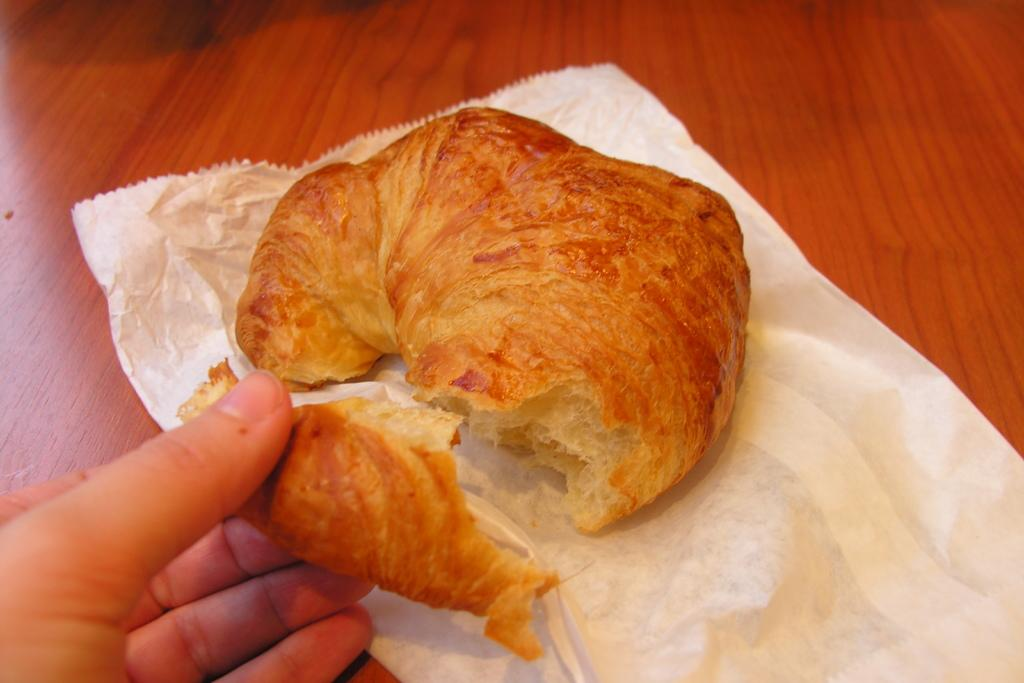What type of food is visible in the image? The food in the image is brown in color. How is the food being presented? The food is on a paper. Who is holding the food in the image? A person's hand is holding the food. What is the color of the background in the image? The background of the image is brown. What type of apparel is the mom wearing in the image? There is no mom present in the image, so it is not possible to determine what type of apparel she might be wearing. 